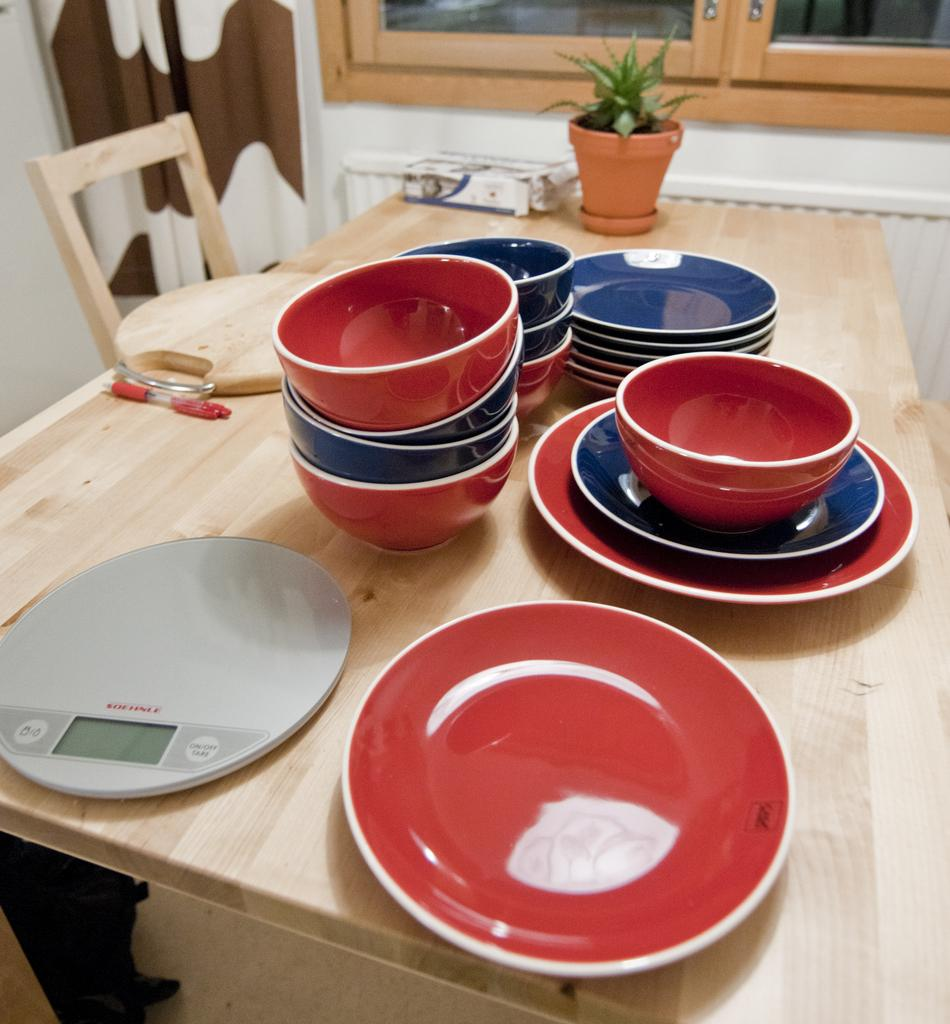<image>
Provide a brief description of the given image. The button to the right of the display is how one turns the hot plate on or off. 